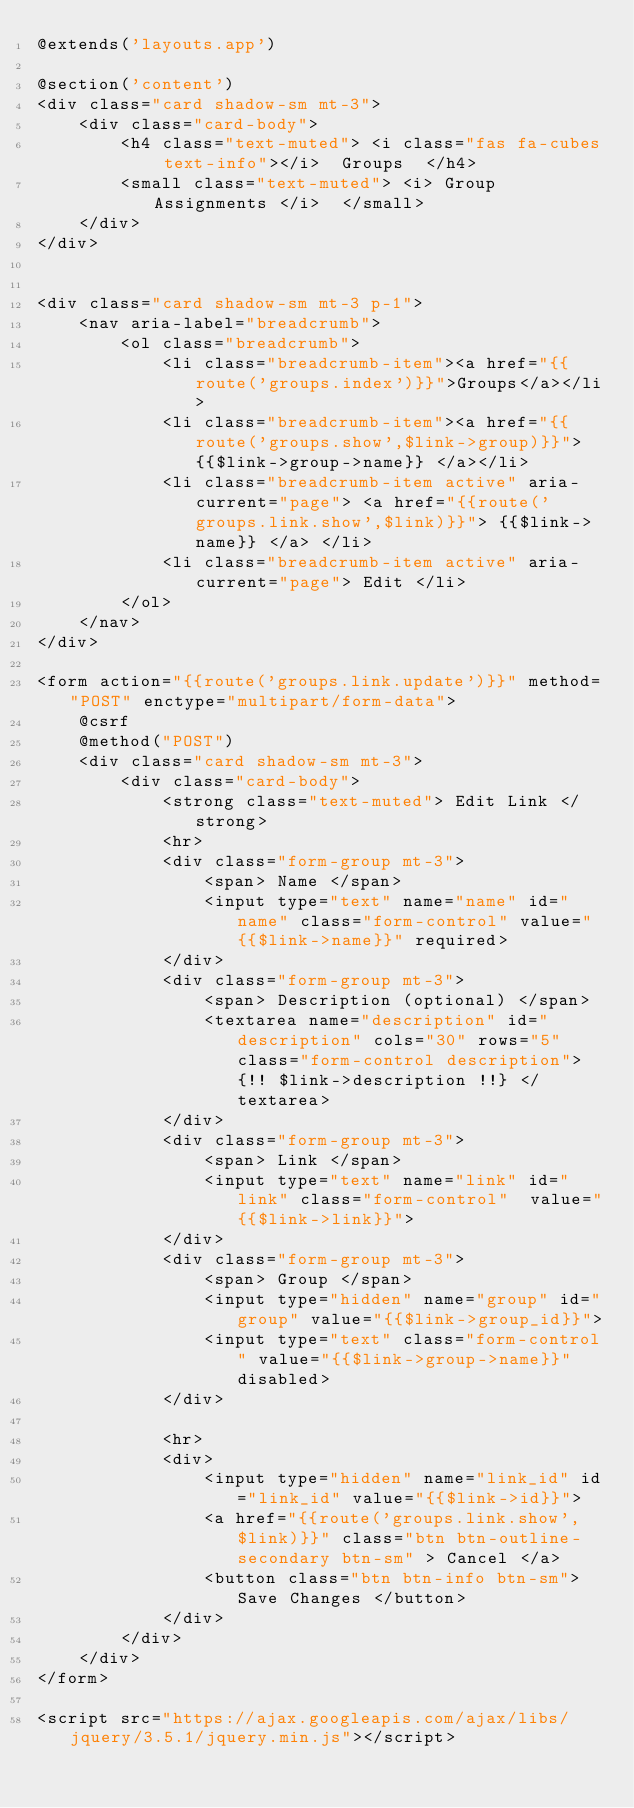<code> <loc_0><loc_0><loc_500><loc_500><_PHP_>@extends('layouts.app')

@section('content')
<div class="card shadow-sm mt-3">
    <div class="card-body">
        <h4 class="text-muted"> <i class="fas fa-cubes text-info"></i>  Groups  </h4>
        <small class="text-muted"> <i> Group Assignments </i>  </small>
    </div>
</div>


<div class="card shadow-sm mt-3 p-1"> 
    <nav aria-label="breadcrumb">
        <ol class="breadcrumb">
            <li class="breadcrumb-item"><a href="{{route('groups.index')}}">Groups</a></li>
            <li class="breadcrumb-item"><a href="{{route('groups.show',$link->group)}}"> {{$link->group->name}} </a></li>
            <li class="breadcrumb-item active" aria-current="page"> <a href="{{route('groups.link.show',$link)}}"> {{$link->name}} </a> </li>
            <li class="breadcrumb-item active" aria-current="page"> Edit </li>
        </ol>
    </nav>
</div>

<form action="{{route('groups.link.update')}}" method="POST" enctype="multipart/form-data">
    @csrf
    @method("POST")
    <div class="card shadow-sm mt-3">
        <div class="card-body">
            <strong class="text-muted"> Edit Link </strong>
            <hr>
            <div class="form-group mt-3">
                <span> Name </span>
                <input type="text" name="name" id="name" class="form-control" value="{{$link->name}}" required>
            </div>
            <div class="form-group mt-3">
                <span> Description (optional) </span>
                <textarea name="description" id="description" cols="30" rows="5" class="form-control description"> {!! $link->description !!} </textarea>
            </div>
            <div class="form-group mt-3">
                <span> Link </span>
                <input type="text" name="link" id="link" class="form-control"  value="{{$link->link}}">
            </div>
            <div class="form-group mt-3">
                <span> Group </span>
                <input type="hidden" name="group" id="group" value="{{$link->group_id}}">
                <input type="text" class="form-control" value="{{$link->group->name}}" disabled>
            </div>

            <hr>
            <div>
                <input type="hidden" name="link_id" id="link_id" value="{{$link->id}}">
                <a href="{{route('groups.link.show',$link)}}" class="btn btn-outline-secondary btn-sm" > Cancel </a>
                <button class="btn btn-info btn-sm"> Save Changes </button>
            </div>
        </div>
    </div>
</form>

<script src="https://ajax.googleapis.com/ajax/libs/jquery/3.5.1/jquery.min.js"></script></code> 